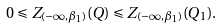Convert formula to latex. <formula><loc_0><loc_0><loc_500><loc_500>0 \leqslant Z _ { ( - \infty , \beta _ { 1 } ) } ( Q ) \leqslant Z _ { ( - \infty , \beta _ { 1 } ) } ( Q _ { 1 } ) .</formula> 